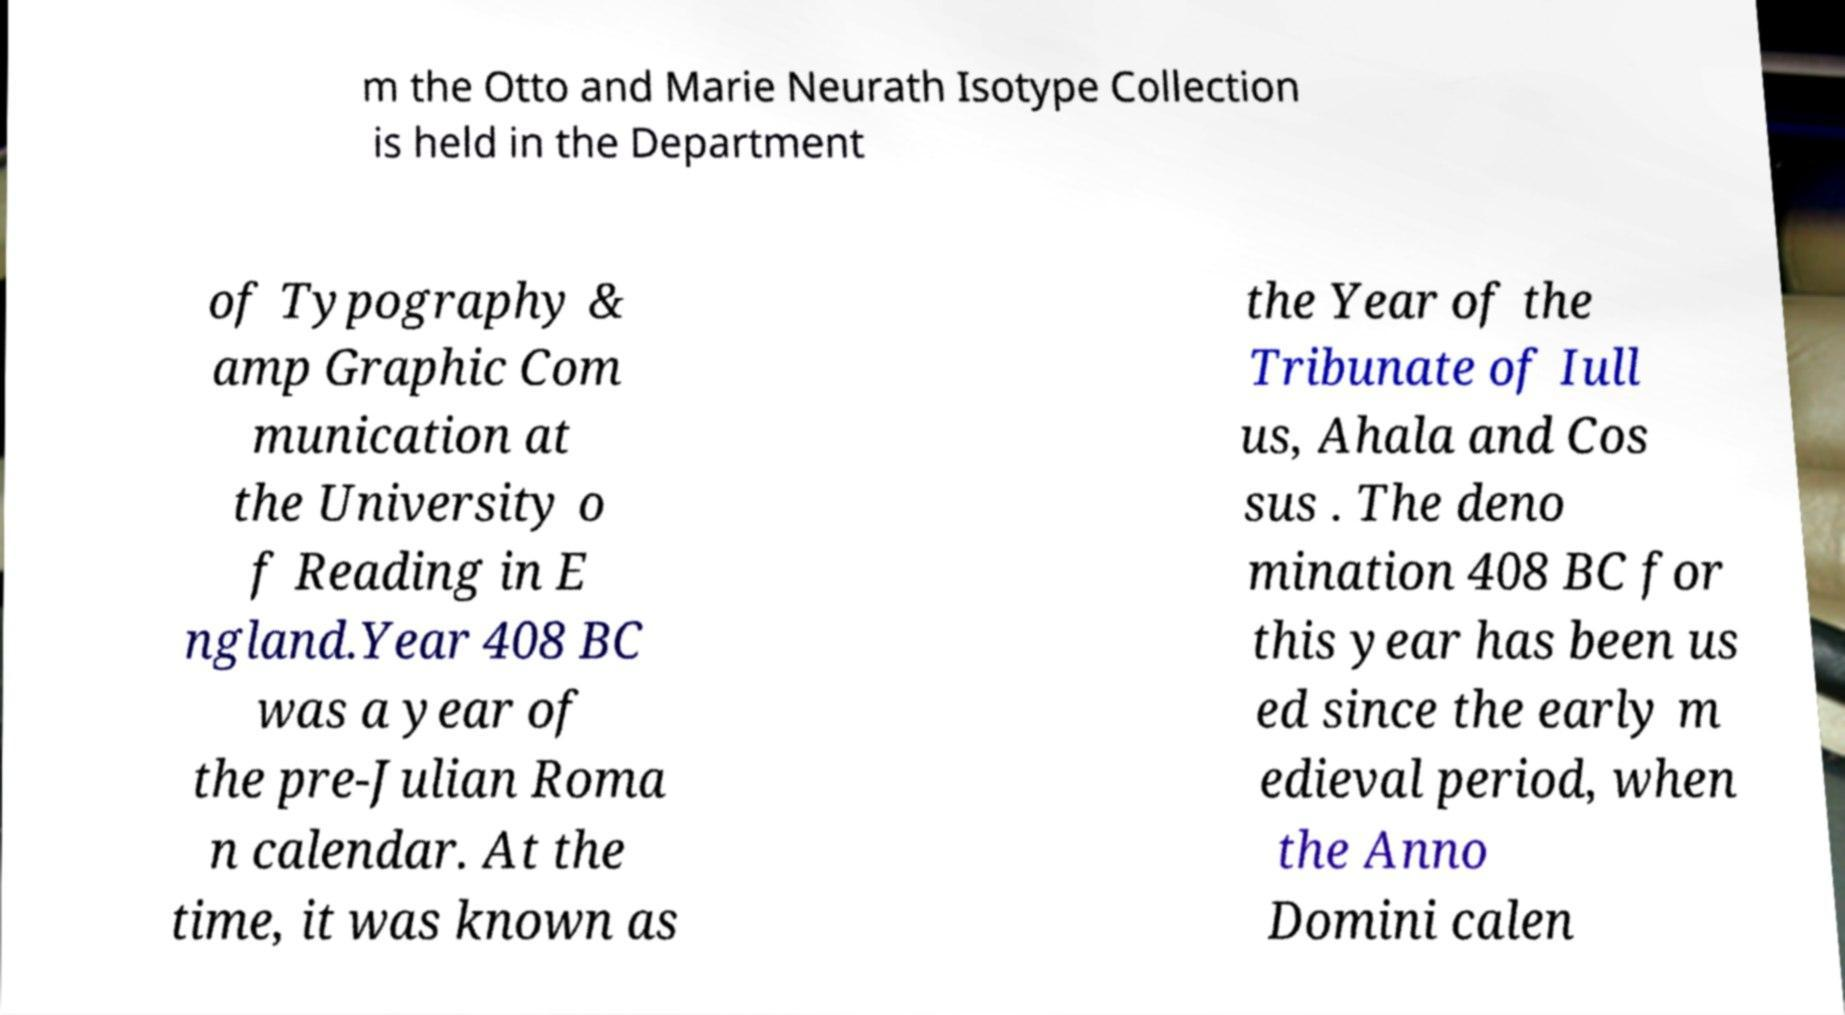Could you extract and type out the text from this image? m the Otto and Marie Neurath Isotype Collection is held in the Department of Typography & amp Graphic Com munication at the University o f Reading in E ngland.Year 408 BC was a year of the pre-Julian Roma n calendar. At the time, it was known as the Year of the Tribunate of Iull us, Ahala and Cos sus . The deno mination 408 BC for this year has been us ed since the early m edieval period, when the Anno Domini calen 